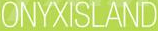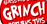Transcribe the words shown in these images in order, separated by a semicolon. ONYXISLAND; GRINGH 